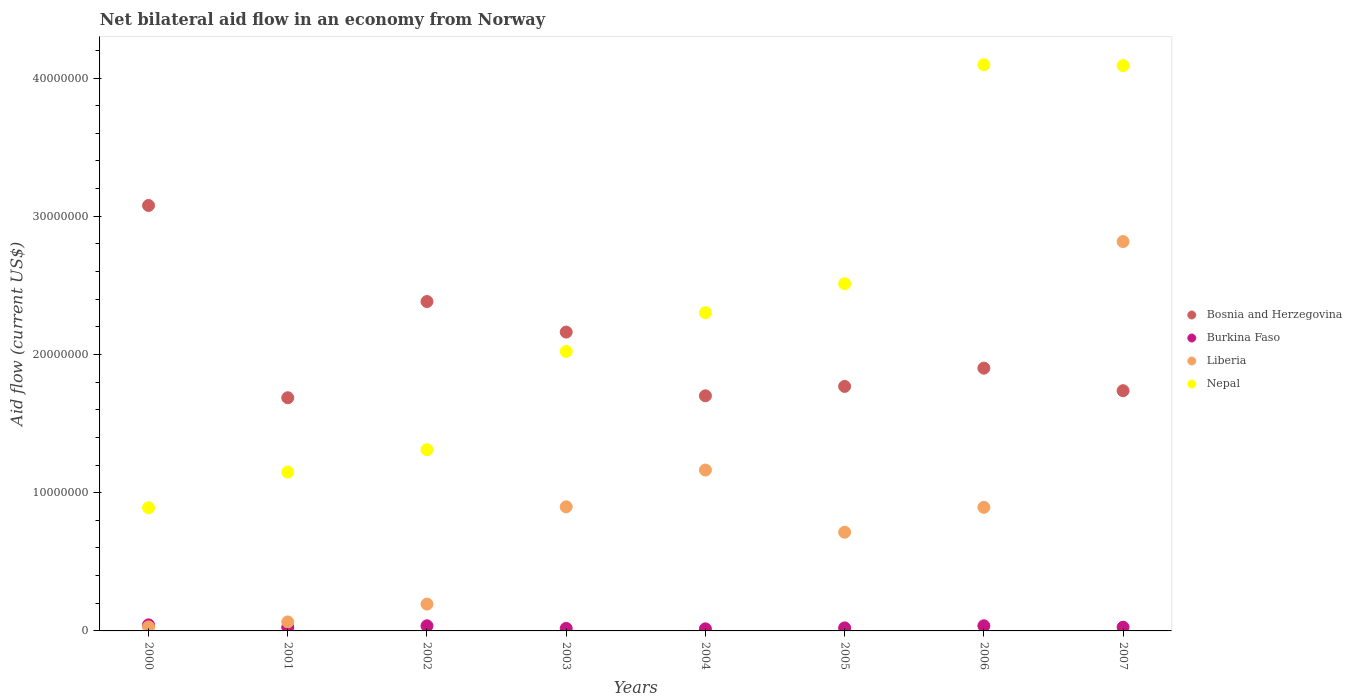How many different coloured dotlines are there?
Ensure brevity in your answer.  4. Is the number of dotlines equal to the number of legend labels?
Make the answer very short. Yes. What is the net bilateral aid flow in Burkina Faso in 2006?
Your response must be concise. 3.70e+05. Across all years, what is the maximum net bilateral aid flow in Liberia?
Give a very brief answer. 2.82e+07. Across all years, what is the minimum net bilateral aid flow in Liberia?
Provide a short and direct response. 2.90e+05. In which year was the net bilateral aid flow in Burkina Faso minimum?
Provide a short and direct response. 2004. What is the total net bilateral aid flow in Bosnia and Herzegovina in the graph?
Your answer should be very brief. 1.64e+08. What is the difference between the net bilateral aid flow in Nepal in 2000 and that in 2007?
Your answer should be compact. -3.20e+07. What is the difference between the net bilateral aid flow in Nepal in 2006 and the net bilateral aid flow in Liberia in 2002?
Provide a short and direct response. 3.90e+07. What is the average net bilateral aid flow in Liberia per year?
Your answer should be very brief. 8.47e+06. In the year 2006, what is the difference between the net bilateral aid flow in Burkina Faso and net bilateral aid flow in Bosnia and Herzegovina?
Provide a succinct answer. -1.86e+07. In how many years, is the net bilateral aid flow in Nepal greater than 16000000 US$?
Keep it short and to the point. 5. What is the ratio of the net bilateral aid flow in Bosnia and Herzegovina in 2001 to that in 2007?
Offer a very short reply. 0.97. Is the difference between the net bilateral aid flow in Burkina Faso in 2000 and 2002 greater than the difference between the net bilateral aid flow in Bosnia and Herzegovina in 2000 and 2002?
Ensure brevity in your answer.  No. What is the difference between the highest and the second highest net bilateral aid flow in Liberia?
Keep it short and to the point. 1.65e+07. What is the difference between the highest and the lowest net bilateral aid flow in Liberia?
Ensure brevity in your answer.  2.79e+07. In how many years, is the net bilateral aid flow in Bosnia and Herzegovina greater than the average net bilateral aid flow in Bosnia and Herzegovina taken over all years?
Make the answer very short. 3. Is the sum of the net bilateral aid flow in Liberia in 2001 and 2005 greater than the maximum net bilateral aid flow in Bosnia and Herzegovina across all years?
Keep it short and to the point. No. Is it the case that in every year, the sum of the net bilateral aid flow in Nepal and net bilateral aid flow in Liberia  is greater than the net bilateral aid flow in Bosnia and Herzegovina?
Your answer should be compact. No. Does the net bilateral aid flow in Bosnia and Herzegovina monotonically increase over the years?
Your answer should be very brief. No. Is the net bilateral aid flow in Liberia strictly greater than the net bilateral aid flow in Bosnia and Herzegovina over the years?
Keep it short and to the point. No. Is the net bilateral aid flow in Burkina Faso strictly less than the net bilateral aid flow in Bosnia and Herzegovina over the years?
Provide a short and direct response. Yes. Does the graph contain any zero values?
Give a very brief answer. No. How many legend labels are there?
Offer a terse response. 4. What is the title of the graph?
Make the answer very short. Net bilateral aid flow in an economy from Norway. Does "Kyrgyz Republic" appear as one of the legend labels in the graph?
Provide a succinct answer. No. What is the label or title of the Y-axis?
Your answer should be very brief. Aid flow (current US$). What is the Aid flow (current US$) in Bosnia and Herzegovina in 2000?
Make the answer very short. 3.08e+07. What is the Aid flow (current US$) in Burkina Faso in 2000?
Provide a succinct answer. 4.40e+05. What is the Aid flow (current US$) of Liberia in 2000?
Offer a very short reply. 2.90e+05. What is the Aid flow (current US$) in Nepal in 2000?
Keep it short and to the point. 8.91e+06. What is the Aid flow (current US$) in Bosnia and Herzegovina in 2001?
Give a very brief answer. 1.69e+07. What is the Aid flow (current US$) in Liberia in 2001?
Keep it short and to the point. 6.50e+05. What is the Aid flow (current US$) of Nepal in 2001?
Keep it short and to the point. 1.15e+07. What is the Aid flow (current US$) in Bosnia and Herzegovina in 2002?
Your answer should be very brief. 2.38e+07. What is the Aid flow (current US$) of Liberia in 2002?
Ensure brevity in your answer.  1.94e+06. What is the Aid flow (current US$) of Nepal in 2002?
Offer a terse response. 1.31e+07. What is the Aid flow (current US$) of Bosnia and Herzegovina in 2003?
Offer a terse response. 2.16e+07. What is the Aid flow (current US$) in Burkina Faso in 2003?
Ensure brevity in your answer.  1.80e+05. What is the Aid flow (current US$) of Liberia in 2003?
Provide a short and direct response. 8.98e+06. What is the Aid flow (current US$) of Nepal in 2003?
Keep it short and to the point. 2.02e+07. What is the Aid flow (current US$) of Bosnia and Herzegovina in 2004?
Keep it short and to the point. 1.70e+07. What is the Aid flow (current US$) of Liberia in 2004?
Your response must be concise. 1.16e+07. What is the Aid flow (current US$) of Nepal in 2004?
Offer a terse response. 2.30e+07. What is the Aid flow (current US$) in Bosnia and Herzegovina in 2005?
Ensure brevity in your answer.  1.77e+07. What is the Aid flow (current US$) of Burkina Faso in 2005?
Provide a succinct answer. 2.20e+05. What is the Aid flow (current US$) in Liberia in 2005?
Offer a very short reply. 7.14e+06. What is the Aid flow (current US$) in Nepal in 2005?
Offer a very short reply. 2.51e+07. What is the Aid flow (current US$) of Bosnia and Herzegovina in 2006?
Your response must be concise. 1.90e+07. What is the Aid flow (current US$) of Liberia in 2006?
Offer a terse response. 8.94e+06. What is the Aid flow (current US$) in Nepal in 2006?
Make the answer very short. 4.10e+07. What is the Aid flow (current US$) of Bosnia and Herzegovina in 2007?
Give a very brief answer. 1.74e+07. What is the Aid flow (current US$) in Liberia in 2007?
Offer a terse response. 2.82e+07. What is the Aid flow (current US$) in Nepal in 2007?
Your answer should be very brief. 4.09e+07. Across all years, what is the maximum Aid flow (current US$) of Bosnia and Herzegovina?
Give a very brief answer. 3.08e+07. Across all years, what is the maximum Aid flow (current US$) of Liberia?
Give a very brief answer. 2.82e+07. Across all years, what is the maximum Aid flow (current US$) in Nepal?
Give a very brief answer. 4.10e+07. Across all years, what is the minimum Aid flow (current US$) in Bosnia and Herzegovina?
Provide a succinct answer. 1.69e+07. Across all years, what is the minimum Aid flow (current US$) of Nepal?
Your answer should be compact. 8.91e+06. What is the total Aid flow (current US$) in Bosnia and Herzegovina in the graph?
Offer a very short reply. 1.64e+08. What is the total Aid flow (current US$) of Burkina Faso in the graph?
Your response must be concise. 2.27e+06. What is the total Aid flow (current US$) in Liberia in the graph?
Keep it short and to the point. 6.78e+07. What is the total Aid flow (current US$) in Nepal in the graph?
Your response must be concise. 1.84e+08. What is the difference between the Aid flow (current US$) of Bosnia and Herzegovina in 2000 and that in 2001?
Offer a terse response. 1.39e+07. What is the difference between the Aid flow (current US$) of Liberia in 2000 and that in 2001?
Make the answer very short. -3.60e+05. What is the difference between the Aid flow (current US$) of Nepal in 2000 and that in 2001?
Your response must be concise. -2.58e+06. What is the difference between the Aid flow (current US$) of Bosnia and Herzegovina in 2000 and that in 2002?
Ensure brevity in your answer.  6.95e+06. What is the difference between the Aid flow (current US$) of Burkina Faso in 2000 and that in 2002?
Your answer should be compact. 7.00e+04. What is the difference between the Aid flow (current US$) in Liberia in 2000 and that in 2002?
Provide a short and direct response. -1.65e+06. What is the difference between the Aid flow (current US$) in Nepal in 2000 and that in 2002?
Offer a terse response. -4.20e+06. What is the difference between the Aid flow (current US$) in Bosnia and Herzegovina in 2000 and that in 2003?
Your response must be concise. 9.16e+06. What is the difference between the Aid flow (current US$) in Liberia in 2000 and that in 2003?
Ensure brevity in your answer.  -8.69e+06. What is the difference between the Aid flow (current US$) in Nepal in 2000 and that in 2003?
Ensure brevity in your answer.  -1.13e+07. What is the difference between the Aid flow (current US$) in Bosnia and Herzegovina in 2000 and that in 2004?
Provide a short and direct response. 1.38e+07. What is the difference between the Aid flow (current US$) of Liberia in 2000 and that in 2004?
Keep it short and to the point. -1.14e+07. What is the difference between the Aid flow (current US$) of Nepal in 2000 and that in 2004?
Your response must be concise. -1.41e+07. What is the difference between the Aid flow (current US$) in Bosnia and Herzegovina in 2000 and that in 2005?
Provide a short and direct response. 1.31e+07. What is the difference between the Aid flow (current US$) of Burkina Faso in 2000 and that in 2005?
Ensure brevity in your answer.  2.20e+05. What is the difference between the Aid flow (current US$) of Liberia in 2000 and that in 2005?
Make the answer very short. -6.85e+06. What is the difference between the Aid flow (current US$) of Nepal in 2000 and that in 2005?
Ensure brevity in your answer.  -1.62e+07. What is the difference between the Aid flow (current US$) of Bosnia and Herzegovina in 2000 and that in 2006?
Offer a terse response. 1.18e+07. What is the difference between the Aid flow (current US$) in Liberia in 2000 and that in 2006?
Make the answer very short. -8.65e+06. What is the difference between the Aid flow (current US$) in Nepal in 2000 and that in 2006?
Keep it short and to the point. -3.20e+07. What is the difference between the Aid flow (current US$) in Bosnia and Herzegovina in 2000 and that in 2007?
Your answer should be very brief. 1.34e+07. What is the difference between the Aid flow (current US$) of Liberia in 2000 and that in 2007?
Give a very brief answer. -2.79e+07. What is the difference between the Aid flow (current US$) in Nepal in 2000 and that in 2007?
Provide a short and direct response. -3.20e+07. What is the difference between the Aid flow (current US$) of Bosnia and Herzegovina in 2001 and that in 2002?
Your answer should be compact. -6.96e+06. What is the difference between the Aid flow (current US$) of Liberia in 2001 and that in 2002?
Provide a short and direct response. -1.29e+06. What is the difference between the Aid flow (current US$) in Nepal in 2001 and that in 2002?
Ensure brevity in your answer.  -1.62e+06. What is the difference between the Aid flow (current US$) of Bosnia and Herzegovina in 2001 and that in 2003?
Offer a terse response. -4.75e+06. What is the difference between the Aid flow (current US$) of Liberia in 2001 and that in 2003?
Make the answer very short. -8.33e+06. What is the difference between the Aid flow (current US$) in Nepal in 2001 and that in 2003?
Give a very brief answer. -8.73e+06. What is the difference between the Aid flow (current US$) in Bosnia and Herzegovina in 2001 and that in 2004?
Ensure brevity in your answer.  -1.40e+05. What is the difference between the Aid flow (current US$) of Liberia in 2001 and that in 2004?
Your answer should be very brief. -1.10e+07. What is the difference between the Aid flow (current US$) in Nepal in 2001 and that in 2004?
Give a very brief answer. -1.15e+07. What is the difference between the Aid flow (current US$) of Bosnia and Herzegovina in 2001 and that in 2005?
Your answer should be very brief. -8.20e+05. What is the difference between the Aid flow (current US$) in Liberia in 2001 and that in 2005?
Offer a very short reply. -6.49e+06. What is the difference between the Aid flow (current US$) in Nepal in 2001 and that in 2005?
Keep it short and to the point. -1.36e+07. What is the difference between the Aid flow (current US$) of Bosnia and Herzegovina in 2001 and that in 2006?
Your answer should be very brief. -2.14e+06. What is the difference between the Aid flow (current US$) of Burkina Faso in 2001 and that in 2006?
Your response must be concise. -1.00e+05. What is the difference between the Aid flow (current US$) of Liberia in 2001 and that in 2006?
Provide a succinct answer. -8.29e+06. What is the difference between the Aid flow (current US$) of Nepal in 2001 and that in 2006?
Your response must be concise. -2.95e+07. What is the difference between the Aid flow (current US$) of Bosnia and Herzegovina in 2001 and that in 2007?
Offer a terse response. -5.10e+05. What is the difference between the Aid flow (current US$) of Burkina Faso in 2001 and that in 2007?
Your answer should be very brief. 0. What is the difference between the Aid flow (current US$) of Liberia in 2001 and that in 2007?
Offer a terse response. -2.75e+07. What is the difference between the Aid flow (current US$) of Nepal in 2001 and that in 2007?
Provide a succinct answer. -2.94e+07. What is the difference between the Aid flow (current US$) of Bosnia and Herzegovina in 2002 and that in 2003?
Your response must be concise. 2.21e+06. What is the difference between the Aid flow (current US$) in Burkina Faso in 2002 and that in 2003?
Make the answer very short. 1.90e+05. What is the difference between the Aid flow (current US$) of Liberia in 2002 and that in 2003?
Ensure brevity in your answer.  -7.04e+06. What is the difference between the Aid flow (current US$) of Nepal in 2002 and that in 2003?
Your response must be concise. -7.11e+06. What is the difference between the Aid flow (current US$) of Bosnia and Herzegovina in 2002 and that in 2004?
Offer a very short reply. 6.82e+06. What is the difference between the Aid flow (current US$) in Burkina Faso in 2002 and that in 2004?
Provide a short and direct response. 2.20e+05. What is the difference between the Aid flow (current US$) in Liberia in 2002 and that in 2004?
Make the answer very short. -9.70e+06. What is the difference between the Aid flow (current US$) in Nepal in 2002 and that in 2004?
Provide a short and direct response. -9.91e+06. What is the difference between the Aid flow (current US$) of Bosnia and Herzegovina in 2002 and that in 2005?
Provide a succinct answer. 6.14e+06. What is the difference between the Aid flow (current US$) in Liberia in 2002 and that in 2005?
Your answer should be very brief. -5.20e+06. What is the difference between the Aid flow (current US$) of Nepal in 2002 and that in 2005?
Provide a short and direct response. -1.20e+07. What is the difference between the Aid flow (current US$) in Bosnia and Herzegovina in 2002 and that in 2006?
Give a very brief answer. 4.82e+06. What is the difference between the Aid flow (current US$) in Liberia in 2002 and that in 2006?
Offer a very short reply. -7.00e+06. What is the difference between the Aid flow (current US$) in Nepal in 2002 and that in 2006?
Make the answer very short. -2.78e+07. What is the difference between the Aid flow (current US$) of Bosnia and Herzegovina in 2002 and that in 2007?
Keep it short and to the point. 6.45e+06. What is the difference between the Aid flow (current US$) of Burkina Faso in 2002 and that in 2007?
Make the answer very short. 1.00e+05. What is the difference between the Aid flow (current US$) of Liberia in 2002 and that in 2007?
Ensure brevity in your answer.  -2.62e+07. What is the difference between the Aid flow (current US$) of Nepal in 2002 and that in 2007?
Provide a succinct answer. -2.78e+07. What is the difference between the Aid flow (current US$) in Bosnia and Herzegovina in 2003 and that in 2004?
Make the answer very short. 4.61e+06. What is the difference between the Aid flow (current US$) in Liberia in 2003 and that in 2004?
Provide a succinct answer. -2.66e+06. What is the difference between the Aid flow (current US$) of Nepal in 2003 and that in 2004?
Offer a very short reply. -2.80e+06. What is the difference between the Aid flow (current US$) of Bosnia and Herzegovina in 2003 and that in 2005?
Your answer should be very brief. 3.93e+06. What is the difference between the Aid flow (current US$) in Liberia in 2003 and that in 2005?
Your response must be concise. 1.84e+06. What is the difference between the Aid flow (current US$) in Nepal in 2003 and that in 2005?
Offer a very short reply. -4.90e+06. What is the difference between the Aid flow (current US$) in Bosnia and Herzegovina in 2003 and that in 2006?
Ensure brevity in your answer.  2.61e+06. What is the difference between the Aid flow (current US$) of Burkina Faso in 2003 and that in 2006?
Give a very brief answer. -1.90e+05. What is the difference between the Aid flow (current US$) in Liberia in 2003 and that in 2006?
Provide a short and direct response. 4.00e+04. What is the difference between the Aid flow (current US$) in Nepal in 2003 and that in 2006?
Make the answer very short. -2.07e+07. What is the difference between the Aid flow (current US$) in Bosnia and Herzegovina in 2003 and that in 2007?
Offer a terse response. 4.24e+06. What is the difference between the Aid flow (current US$) in Burkina Faso in 2003 and that in 2007?
Make the answer very short. -9.00e+04. What is the difference between the Aid flow (current US$) in Liberia in 2003 and that in 2007?
Your answer should be very brief. -1.92e+07. What is the difference between the Aid flow (current US$) of Nepal in 2003 and that in 2007?
Offer a terse response. -2.07e+07. What is the difference between the Aid flow (current US$) in Bosnia and Herzegovina in 2004 and that in 2005?
Your answer should be very brief. -6.80e+05. What is the difference between the Aid flow (current US$) of Liberia in 2004 and that in 2005?
Provide a succinct answer. 4.50e+06. What is the difference between the Aid flow (current US$) of Nepal in 2004 and that in 2005?
Your response must be concise. -2.10e+06. What is the difference between the Aid flow (current US$) in Bosnia and Herzegovina in 2004 and that in 2006?
Your answer should be compact. -2.00e+06. What is the difference between the Aid flow (current US$) in Burkina Faso in 2004 and that in 2006?
Give a very brief answer. -2.20e+05. What is the difference between the Aid flow (current US$) of Liberia in 2004 and that in 2006?
Your answer should be very brief. 2.70e+06. What is the difference between the Aid flow (current US$) in Nepal in 2004 and that in 2006?
Give a very brief answer. -1.79e+07. What is the difference between the Aid flow (current US$) of Bosnia and Herzegovina in 2004 and that in 2007?
Make the answer very short. -3.70e+05. What is the difference between the Aid flow (current US$) in Burkina Faso in 2004 and that in 2007?
Give a very brief answer. -1.20e+05. What is the difference between the Aid flow (current US$) of Liberia in 2004 and that in 2007?
Provide a succinct answer. -1.65e+07. What is the difference between the Aid flow (current US$) of Nepal in 2004 and that in 2007?
Keep it short and to the point. -1.79e+07. What is the difference between the Aid flow (current US$) in Bosnia and Herzegovina in 2005 and that in 2006?
Make the answer very short. -1.32e+06. What is the difference between the Aid flow (current US$) in Burkina Faso in 2005 and that in 2006?
Make the answer very short. -1.50e+05. What is the difference between the Aid flow (current US$) of Liberia in 2005 and that in 2006?
Your answer should be very brief. -1.80e+06. What is the difference between the Aid flow (current US$) of Nepal in 2005 and that in 2006?
Offer a very short reply. -1.58e+07. What is the difference between the Aid flow (current US$) in Bosnia and Herzegovina in 2005 and that in 2007?
Your answer should be very brief. 3.10e+05. What is the difference between the Aid flow (current US$) of Liberia in 2005 and that in 2007?
Provide a succinct answer. -2.10e+07. What is the difference between the Aid flow (current US$) in Nepal in 2005 and that in 2007?
Provide a short and direct response. -1.58e+07. What is the difference between the Aid flow (current US$) in Bosnia and Herzegovina in 2006 and that in 2007?
Give a very brief answer. 1.63e+06. What is the difference between the Aid flow (current US$) of Liberia in 2006 and that in 2007?
Give a very brief answer. -1.92e+07. What is the difference between the Aid flow (current US$) of Bosnia and Herzegovina in 2000 and the Aid flow (current US$) of Burkina Faso in 2001?
Your answer should be compact. 3.05e+07. What is the difference between the Aid flow (current US$) in Bosnia and Herzegovina in 2000 and the Aid flow (current US$) in Liberia in 2001?
Provide a succinct answer. 3.01e+07. What is the difference between the Aid flow (current US$) of Bosnia and Herzegovina in 2000 and the Aid flow (current US$) of Nepal in 2001?
Give a very brief answer. 1.93e+07. What is the difference between the Aid flow (current US$) in Burkina Faso in 2000 and the Aid flow (current US$) in Liberia in 2001?
Make the answer very short. -2.10e+05. What is the difference between the Aid flow (current US$) in Burkina Faso in 2000 and the Aid flow (current US$) in Nepal in 2001?
Your answer should be very brief. -1.10e+07. What is the difference between the Aid flow (current US$) of Liberia in 2000 and the Aid flow (current US$) of Nepal in 2001?
Provide a succinct answer. -1.12e+07. What is the difference between the Aid flow (current US$) in Bosnia and Herzegovina in 2000 and the Aid flow (current US$) in Burkina Faso in 2002?
Offer a very short reply. 3.04e+07. What is the difference between the Aid flow (current US$) in Bosnia and Herzegovina in 2000 and the Aid flow (current US$) in Liberia in 2002?
Make the answer very short. 2.88e+07. What is the difference between the Aid flow (current US$) in Bosnia and Herzegovina in 2000 and the Aid flow (current US$) in Nepal in 2002?
Provide a succinct answer. 1.77e+07. What is the difference between the Aid flow (current US$) in Burkina Faso in 2000 and the Aid flow (current US$) in Liberia in 2002?
Provide a short and direct response. -1.50e+06. What is the difference between the Aid flow (current US$) of Burkina Faso in 2000 and the Aid flow (current US$) of Nepal in 2002?
Your answer should be compact. -1.27e+07. What is the difference between the Aid flow (current US$) of Liberia in 2000 and the Aid flow (current US$) of Nepal in 2002?
Give a very brief answer. -1.28e+07. What is the difference between the Aid flow (current US$) in Bosnia and Herzegovina in 2000 and the Aid flow (current US$) in Burkina Faso in 2003?
Ensure brevity in your answer.  3.06e+07. What is the difference between the Aid flow (current US$) in Bosnia and Herzegovina in 2000 and the Aid flow (current US$) in Liberia in 2003?
Ensure brevity in your answer.  2.18e+07. What is the difference between the Aid flow (current US$) in Bosnia and Herzegovina in 2000 and the Aid flow (current US$) in Nepal in 2003?
Make the answer very short. 1.06e+07. What is the difference between the Aid flow (current US$) of Burkina Faso in 2000 and the Aid flow (current US$) of Liberia in 2003?
Offer a terse response. -8.54e+06. What is the difference between the Aid flow (current US$) of Burkina Faso in 2000 and the Aid flow (current US$) of Nepal in 2003?
Your answer should be very brief. -1.98e+07. What is the difference between the Aid flow (current US$) of Liberia in 2000 and the Aid flow (current US$) of Nepal in 2003?
Offer a terse response. -1.99e+07. What is the difference between the Aid flow (current US$) in Bosnia and Herzegovina in 2000 and the Aid flow (current US$) in Burkina Faso in 2004?
Offer a very short reply. 3.06e+07. What is the difference between the Aid flow (current US$) in Bosnia and Herzegovina in 2000 and the Aid flow (current US$) in Liberia in 2004?
Provide a short and direct response. 1.91e+07. What is the difference between the Aid flow (current US$) in Bosnia and Herzegovina in 2000 and the Aid flow (current US$) in Nepal in 2004?
Offer a very short reply. 7.76e+06. What is the difference between the Aid flow (current US$) of Burkina Faso in 2000 and the Aid flow (current US$) of Liberia in 2004?
Your answer should be compact. -1.12e+07. What is the difference between the Aid flow (current US$) of Burkina Faso in 2000 and the Aid flow (current US$) of Nepal in 2004?
Ensure brevity in your answer.  -2.26e+07. What is the difference between the Aid flow (current US$) of Liberia in 2000 and the Aid flow (current US$) of Nepal in 2004?
Your response must be concise. -2.27e+07. What is the difference between the Aid flow (current US$) of Bosnia and Herzegovina in 2000 and the Aid flow (current US$) of Burkina Faso in 2005?
Ensure brevity in your answer.  3.06e+07. What is the difference between the Aid flow (current US$) of Bosnia and Herzegovina in 2000 and the Aid flow (current US$) of Liberia in 2005?
Provide a short and direct response. 2.36e+07. What is the difference between the Aid flow (current US$) of Bosnia and Herzegovina in 2000 and the Aid flow (current US$) of Nepal in 2005?
Give a very brief answer. 5.66e+06. What is the difference between the Aid flow (current US$) in Burkina Faso in 2000 and the Aid flow (current US$) in Liberia in 2005?
Keep it short and to the point. -6.70e+06. What is the difference between the Aid flow (current US$) of Burkina Faso in 2000 and the Aid flow (current US$) of Nepal in 2005?
Keep it short and to the point. -2.47e+07. What is the difference between the Aid flow (current US$) in Liberia in 2000 and the Aid flow (current US$) in Nepal in 2005?
Offer a terse response. -2.48e+07. What is the difference between the Aid flow (current US$) in Bosnia and Herzegovina in 2000 and the Aid flow (current US$) in Burkina Faso in 2006?
Your response must be concise. 3.04e+07. What is the difference between the Aid flow (current US$) in Bosnia and Herzegovina in 2000 and the Aid flow (current US$) in Liberia in 2006?
Your response must be concise. 2.18e+07. What is the difference between the Aid flow (current US$) in Bosnia and Herzegovina in 2000 and the Aid flow (current US$) in Nepal in 2006?
Provide a short and direct response. -1.02e+07. What is the difference between the Aid flow (current US$) in Burkina Faso in 2000 and the Aid flow (current US$) in Liberia in 2006?
Offer a terse response. -8.50e+06. What is the difference between the Aid flow (current US$) in Burkina Faso in 2000 and the Aid flow (current US$) in Nepal in 2006?
Provide a succinct answer. -4.05e+07. What is the difference between the Aid flow (current US$) of Liberia in 2000 and the Aid flow (current US$) of Nepal in 2006?
Your response must be concise. -4.07e+07. What is the difference between the Aid flow (current US$) in Bosnia and Herzegovina in 2000 and the Aid flow (current US$) in Burkina Faso in 2007?
Your answer should be compact. 3.05e+07. What is the difference between the Aid flow (current US$) of Bosnia and Herzegovina in 2000 and the Aid flow (current US$) of Liberia in 2007?
Keep it short and to the point. 2.61e+06. What is the difference between the Aid flow (current US$) of Bosnia and Herzegovina in 2000 and the Aid flow (current US$) of Nepal in 2007?
Offer a very short reply. -1.01e+07. What is the difference between the Aid flow (current US$) in Burkina Faso in 2000 and the Aid flow (current US$) in Liberia in 2007?
Your answer should be compact. -2.77e+07. What is the difference between the Aid flow (current US$) of Burkina Faso in 2000 and the Aid flow (current US$) of Nepal in 2007?
Give a very brief answer. -4.05e+07. What is the difference between the Aid flow (current US$) in Liberia in 2000 and the Aid flow (current US$) in Nepal in 2007?
Your response must be concise. -4.06e+07. What is the difference between the Aid flow (current US$) of Bosnia and Herzegovina in 2001 and the Aid flow (current US$) of Burkina Faso in 2002?
Ensure brevity in your answer.  1.65e+07. What is the difference between the Aid flow (current US$) of Bosnia and Herzegovina in 2001 and the Aid flow (current US$) of Liberia in 2002?
Keep it short and to the point. 1.49e+07. What is the difference between the Aid flow (current US$) of Bosnia and Herzegovina in 2001 and the Aid flow (current US$) of Nepal in 2002?
Offer a very short reply. 3.76e+06. What is the difference between the Aid flow (current US$) of Burkina Faso in 2001 and the Aid flow (current US$) of Liberia in 2002?
Provide a succinct answer. -1.67e+06. What is the difference between the Aid flow (current US$) in Burkina Faso in 2001 and the Aid flow (current US$) in Nepal in 2002?
Provide a succinct answer. -1.28e+07. What is the difference between the Aid flow (current US$) of Liberia in 2001 and the Aid flow (current US$) of Nepal in 2002?
Provide a short and direct response. -1.25e+07. What is the difference between the Aid flow (current US$) of Bosnia and Herzegovina in 2001 and the Aid flow (current US$) of Burkina Faso in 2003?
Offer a very short reply. 1.67e+07. What is the difference between the Aid flow (current US$) in Bosnia and Herzegovina in 2001 and the Aid flow (current US$) in Liberia in 2003?
Provide a short and direct response. 7.89e+06. What is the difference between the Aid flow (current US$) of Bosnia and Herzegovina in 2001 and the Aid flow (current US$) of Nepal in 2003?
Your response must be concise. -3.35e+06. What is the difference between the Aid flow (current US$) in Burkina Faso in 2001 and the Aid flow (current US$) in Liberia in 2003?
Make the answer very short. -8.71e+06. What is the difference between the Aid flow (current US$) in Burkina Faso in 2001 and the Aid flow (current US$) in Nepal in 2003?
Provide a succinct answer. -2.00e+07. What is the difference between the Aid flow (current US$) in Liberia in 2001 and the Aid flow (current US$) in Nepal in 2003?
Your answer should be very brief. -1.96e+07. What is the difference between the Aid flow (current US$) of Bosnia and Herzegovina in 2001 and the Aid flow (current US$) of Burkina Faso in 2004?
Make the answer very short. 1.67e+07. What is the difference between the Aid flow (current US$) in Bosnia and Herzegovina in 2001 and the Aid flow (current US$) in Liberia in 2004?
Keep it short and to the point. 5.23e+06. What is the difference between the Aid flow (current US$) in Bosnia and Herzegovina in 2001 and the Aid flow (current US$) in Nepal in 2004?
Your answer should be very brief. -6.15e+06. What is the difference between the Aid flow (current US$) of Burkina Faso in 2001 and the Aid flow (current US$) of Liberia in 2004?
Your answer should be very brief. -1.14e+07. What is the difference between the Aid flow (current US$) of Burkina Faso in 2001 and the Aid flow (current US$) of Nepal in 2004?
Ensure brevity in your answer.  -2.28e+07. What is the difference between the Aid flow (current US$) in Liberia in 2001 and the Aid flow (current US$) in Nepal in 2004?
Your answer should be compact. -2.24e+07. What is the difference between the Aid flow (current US$) of Bosnia and Herzegovina in 2001 and the Aid flow (current US$) of Burkina Faso in 2005?
Your answer should be compact. 1.66e+07. What is the difference between the Aid flow (current US$) of Bosnia and Herzegovina in 2001 and the Aid flow (current US$) of Liberia in 2005?
Provide a short and direct response. 9.73e+06. What is the difference between the Aid flow (current US$) of Bosnia and Herzegovina in 2001 and the Aid flow (current US$) of Nepal in 2005?
Your answer should be compact. -8.25e+06. What is the difference between the Aid flow (current US$) in Burkina Faso in 2001 and the Aid flow (current US$) in Liberia in 2005?
Ensure brevity in your answer.  -6.87e+06. What is the difference between the Aid flow (current US$) in Burkina Faso in 2001 and the Aid flow (current US$) in Nepal in 2005?
Provide a short and direct response. -2.48e+07. What is the difference between the Aid flow (current US$) in Liberia in 2001 and the Aid flow (current US$) in Nepal in 2005?
Your answer should be compact. -2.45e+07. What is the difference between the Aid flow (current US$) in Bosnia and Herzegovina in 2001 and the Aid flow (current US$) in Burkina Faso in 2006?
Make the answer very short. 1.65e+07. What is the difference between the Aid flow (current US$) of Bosnia and Herzegovina in 2001 and the Aid flow (current US$) of Liberia in 2006?
Offer a terse response. 7.93e+06. What is the difference between the Aid flow (current US$) of Bosnia and Herzegovina in 2001 and the Aid flow (current US$) of Nepal in 2006?
Ensure brevity in your answer.  -2.41e+07. What is the difference between the Aid flow (current US$) in Burkina Faso in 2001 and the Aid flow (current US$) in Liberia in 2006?
Provide a succinct answer. -8.67e+06. What is the difference between the Aid flow (current US$) of Burkina Faso in 2001 and the Aid flow (current US$) of Nepal in 2006?
Offer a terse response. -4.07e+07. What is the difference between the Aid flow (current US$) of Liberia in 2001 and the Aid flow (current US$) of Nepal in 2006?
Your response must be concise. -4.03e+07. What is the difference between the Aid flow (current US$) of Bosnia and Herzegovina in 2001 and the Aid flow (current US$) of Burkina Faso in 2007?
Offer a terse response. 1.66e+07. What is the difference between the Aid flow (current US$) in Bosnia and Herzegovina in 2001 and the Aid flow (current US$) in Liberia in 2007?
Offer a terse response. -1.13e+07. What is the difference between the Aid flow (current US$) in Bosnia and Herzegovina in 2001 and the Aid flow (current US$) in Nepal in 2007?
Ensure brevity in your answer.  -2.40e+07. What is the difference between the Aid flow (current US$) of Burkina Faso in 2001 and the Aid flow (current US$) of Liberia in 2007?
Your answer should be compact. -2.79e+07. What is the difference between the Aid flow (current US$) in Burkina Faso in 2001 and the Aid flow (current US$) in Nepal in 2007?
Keep it short and to the point. -4.06e+07. What is the difference between the Aid flow (current US$) of Liberia in 2001 and the Aid flow (current US$) of Nepal in 2007?
Make the answer very short. -4.02e+07. What is the difference between the Aid flow (current US$) of Bosnia and Herzegovina in 2002 and the Aid flow (current US$) of Burkina Faso in 2003?
Make the answer very short. 2.36e+07. What is the difference between the Aid flow (current US$) in Bosnia and Herzegovina in 2002 and the Aid flow (current US$) in Liberia in 2003?
Give a very brief answer. 1.48e+07. What is the difference between the Aid flow (current US$) of Bosnia and Herzegovina in 2002 and the Aid flow (current US$) of Nepal in 2003?
Keep it short and to the point. 3.61e+06. What is the difference between the Aid flow (current US$) in Burkina Faso in 2002 and the Aid flow (current US$) in Liberia in 2003?
Offer a very short reply. -8.61e+06. What is the difference between the Aid flow (current US$) of Burkina Faso in 2002 and the Aid flow (current US$) of Nepal in 2003?
Your response must be concise. -1.98e+07. What is the difference between the Aid flow (current US$) in Liberia in 2002 and the Aid flow (current US$) in Nepal in 2003?
Give a very brief answer. -1.83e+07. What is the difference between the Aid flow (current US$) in Bosnia and Herzegovina in 2002 and the Aid flow (current US$) in Burkina Faso in 2004?
Offer a very short reply. 2.37e+07. What is the difference between the Aid flow (current US$) of Bosnia and Herzegovina in 2002 and the Aid flow (current US$) of Liberia in 2004?
Offer a very short reply. 1.22e+07. What is the difference between the Aid flow (current US$) in Bosnia and Herzegovina in 2002 and the Aid flow (current US$) in Nepal in 2004?
Make the answer very short. 8.10e+05. What is the difference between the Aid flow (current US$) of Burkina Faso in 2002 and the Aid flow (current US$) of Liberia in 2004?
Your answer should be very brief. -1.13e+07. What is the difference between the Aid flow (current US$) of Burkina Faso in 2002 and the Aid flow (current US$) of Nepal in 2004?
Provide a short and direct response. -2.26e+07. What is the difference between the Aid flow (current US$) in Liberia in 2002 and the Aid flow (current US$) in Nepal in 2004?
Offer a terse response. -2.11e+07. What is the difference between the Aid flow (current US$) in Bosnia and Herzegovina in 2002 and the Aid flow (current US$) in Burkina Faso in 2005?
Make the answer very short. 2.36e+07. What is the difference between the Aid flow (current US$) of Bosnia and Herzegovina in 2002 and the Aid flow (current US$) of Liberia in 2005?
Your answer should be compact. 1.67e+07. What is the difference between the Aid flow (current US$) in Bosnia and Herzegovina in 2002 and the Aid flow (current US$) in Nepal in 2005?
Your answer should be very brief. -1.29e+06. What is the difference between the Aid flow (current US$) of Burkina Faso in 2002 and the Aid flow (current US$) of Liberia in 2005?
Offer a terse response. -6.77e+06. What is the difference between the Aid flow (current US$) of Burkina Faso in 2002 and the Aid flow (current US$) of Nepal in 2005?
Your answer should be very brief. -2.48e+07. What is the difference between the Aid flow (current US$) in Liberia in 2002 and the Aid flow (current US$) in Nepal in 2005?
Your response must be concise. -2.32e+07. What is the difference between the Aid flow (current US$) in Bosnia and Herzegovina in 2002 and the Aid flow (current US$) in Burkina Faso in 2006?
Keep it short and to the point. 2.35e+07. What is the difference between the Aid flow (current US$) in Bosnia and Herzegovina in 2002 and the Aid flow (current US$) in Liberia in 2006?
Offer a terse response. 1.49e+07. What is the difference between the Aid flow (current US$) in Bosnia and Herzegovina in 2002 and the Aid flow (current US$) in Nepal in 2006?
Provide a short and direct response. -1.71e+07. What is the difference between the Aid flow (current US$) of Burkina Faso in 2002 and the Aid flow (current US$) of Liberia in 2006?
Offer a very short reply. -8.57e+06. What is the difference between the Aid flow (current US$) in Burkina Faso in 2002 and the Aid flow (current US$) in Nepal in 2006?
Provide a short and direct response. -4.06e+07. What is the difference between the Aid flow (current US$) in Liberia in 2002 and the Aid flow (current US$) in Nepal in 2006?
Give a very brief answer. -3.90e+07. What is the difference between the Aid flow (current US$) of Bosnia and Herzegovina in 2002 and the Aid flow (current US$) of Burkina Faso in 2007?
Keep it short and to the point. 2.36e+07. What is the difference between the Aid flow (current US$) in Bosnia and Herzegovina in 2002 and the Aid flow (current US$) in Liberia in 2007?
Provide a succinct answer. -4.34e+06. What is the difference between the Aid flow (current US$) in Bosnia and Herzegovina in 2002 and the Aid flow (current US$) in Nepal in 2007?
Give a very brief answer. -1.71e+07. What is the difference between the Aid flow (current US$) of Burkina Faso in 2002 and the Aid flow (current US$) of Liberia in 2007?
Your answer should be very brief. -2.78e+07. What is the difference between the Aid flow (current US$) of Burkina Faso in 2002 and the Aid flow (current US$) of Nepal in 2007?
Offer a very short reply. -4.05e+07. What is the difference between the Aid flow (current US$) in Liberia in 2002 and the Aid flow (current US$) in Nepal in 2007?
Keep it short and to the point. -3.90e+07. What is the difference between the Aid flow (current US$) of Bosnia and Herzegovina in 2003 and the Aid flow (current US$) of Burkina Faso in 2004?
Your answer should be very brief. 2.15e+07. What is the difference between the Aid flow (current US$) of Bosnia and Herzegovina in 2003 and the Aid flow (current US$) of Liberia in 2004?
Give a very brief answer. 9.98e+06. What is the difference between the Aid flow (current US$) in Bosnia and Herzegovina in 2003 and the Aid flow (current US$) in Nepal in 2004?
Provide a succinct answer. -1.40e+06. What is the difference between the Aid flow (current US$) in Burkina Faso in 2003 and the Aid flow (current US$) in Liberia in 2004?
Your answer should be very brief. -1.15e+07. What is the difference between the Aid flow (current US$) in Burkina Faso in 2003 and the Aid flow (current US$) in Nepal in 2004?
Your answer should be very brief. -2.28e+07. What is the difference between the Aid flow (current US$) in Liberia in 2003 and the Aid flow (current US$) in Nepal in 2004?
Your answer should be very brief. -1.40e+07. What is the difference between the Aid flow (current US$) in Bosnia and Herzegovina in 2003 and the Aid flow (current US$) in Burkina Faso in 2005?
Ensure brevity in your answer.  2.14e+07. What is the difference between the Aid flow (current US$) of Bosnia and Herzegovina in 2003 and the Aid flow (current US$) of Liberia in 2005?
Provide a succinct answer. 1.45e+07. What is the difference between the Aid flow (current US$) of Bosnia and Herzegovina in 2003 and the Aid flow (current US$) of Nepal in 2005?
Ensure brevity in your answer.  -3.50e+06. What is the difference between the Aid flow (current US$) of Burkina Faso in 2003 and the Aid flow (current US$) of Liberia in 2005?
Provide a succinct answer. -6.96e+06. What is the difference between the Aid flow (current US$) of Burkina Faso in 2003 and the Aid flow (current US$) of Nepal in 2005?
Your answer should be compact. -2.49e+07. What is the difference between the Aid flow (current US$) in Liberia in 2003 and the Aid flow (current US$) in Nepal in 2005?
Your answer should be compact. -1.61e+07. What is the difference between the Aid flow (current US$) in Bosnia and Herzegovina in 2003 and the Aid flow (current US$) in Burkina Faso in 2006?
Your response must be concise. 2.12e+07. What is the difference between the Aid flow (current US$) in Bosnia and Herzegovina in 2003 and the Aid flow (current US$) in Liberia in 2006?
Provide a short and direct response. 1.27e+07. What is the difference between the Aid flow (current US$) in Bosnia and Herzegovina in 2003 and the Aid flow (current US$) in Nepal in 2006?
Make the answer very short. -1.93e+07. What is the difference between the Aid flow (current US$) in Burkina Faso in 2003 and the Aid flow (current US$) in Liberia in 2006?
Your answer should be very brief. -8.76e+06. What is the difference between the Aid flow (current US$) of Burkina Faso in 2003 and the Aid flow (current US$) of Nepal in 2006?
Give a very brief answer. -4.08e+07. What is the difference between the Aid flow (current US$) of Liberia in 2003 and the Aid flow (current US$) of Nepal in 2006?
Offer a very short reply. -3.20e+07. What is the difference between the Aid flow (current US$) of Bosnia and Herzegovina in 2003 and the Aid flow (current US$) of Burkina Faso in 2007?
Your answer should be very brief. 2.14e+07. What is the difference between the Aid flow (current US$) in Bosnia and Herzegovina in 2003 and the Aid flow (current US$) in Liberia in 2007?
Offer a very short reply. -6.55e+06. What is the difference between the Aid flow (current US$) of Bosnia and Herzegovina in 2003 and the Aid flow (current US$) of Nepal in 2007?
Your answer should be compact. -1.93e+07. What is the difference between the Aid flow (current US$) in Burkina Faso in 2003 and the Aid flow (current US$) in Liberia in 2007?
Your answer should be very brief. -2.80e+07. What is the difference between the Aid flow (current US$) in Burkina Faso in 2003 and the Aid flow (current US$) in Nepal in 2007?
Provide a short and direct response. -4.07e+07. What is the difference between the Aid flow (current US$) of Liberia in 2003 and the Aid flow (current US$) of Nepal in 2007?
Offer a very short reply. -3.19e+07. What is the difference between the Aid flow (current US$) in Bosnia and Herzegovina in 2004 and the Aid flow (current US$) in Burkina Faso in 2005?
Provide a succinct answer. 1.68e+07. What is the difference between the Aid flow (current US$) in Bosnia and Herzegovina in 2004 and the Aid flow (current US$) in Liberia in 2005?
Make the answer very short. 9.87e+06. What is the difference between the Aid flow (current US$) of Bosnia and Herzegovina in 2004 and the Aid flow (current US$) of Nepal in 2005?
Offer a terse response. -8.11e+06. What is the difference between the Aid flow (current US$) in Burkina Faso in 2004 and the Aid flow (current US$) in Liberia in 2005?
Your answer should be compact. -6.99e+06. What is the difference between the Aid flow (current US$) of Burkina Faso in 2004 and the Aid flow (current US$) of Nepal in 2005?
Your answer should be compact. -2.50e+07. What is the difference between the Aid flow (current US$) in Liberia in 2004 and the Aid flow (current US$) in Nepal in 2005?
Make the answer very short. -1.35e+07. What is the difference between the Aid flow (current US$) of Bosnia and Herzegovina in 2004 and the Aid flow (current US$) of Burkina Faso in 2006?
Give a very brief answer. 1.66e+07. What is the difference between the Aid flow (current US$) of Bosnia and Herzegovina in 2004 and the Aid flow (current US$) of Liberia in 2006?
Keep it short and to the point. 8.07e+06. What is the difference between the Aid flow (current US$) of Bosnia and Herzegovina in 2004 and the Aid flow (current US$) of Nepal in 2006?
Provide a short and direct response. -2.40e+07. What is the difference between the Aid flow (current US$) of Burkina Faso in 2004 and the Aid flow (current US$) of Liberia in 2006?
Your answer should be very brief. -8.79e+06. What is the difference between the Aid flow (current US$) in Burkina Faso in 2004 and the Aid flow (current US$) in Nepal in 2006?
Give a very brief answer. -4.08e+07. What is the difference between the Aid flow (current US$) of Liberia in 2004 and the Aid flow (current US$) of Nepal in 2006?
Your response must be concise. -2.93e+07. What is the difference between the Aid flow (current US$) in Bosnia and Herzegovina in 2004 and the Aid flow (current US$) in Burkina Faso in 2007?
Make the answer very short. 1.67e+07. What is the difference between the Aid flow (current US$) in Bosnia and Herzegovina in 2004 and the Aid flow (current US$) in Liberia in 2007?
Ensure brevity in your answer.  -1.12e+07. What is the difference between the Aid flow (current US$) in Bosnia and Herzegovina in 2004 and the Aid flow (current US$) in Nepal in 2007?
Give a very brief answer. -2.39e+07. What is the difference between the Aid flow (current US$) in Burkina Faso in 2004 and the Aid flow (current US$) in Liberia in 2007?
Keep it short and to the point. -2.80e+07. What is the difference between the Aid flow (current US$) of Burkina Faso in 2004 and the Aid flow (current US$) of Nepal in 2007?
Provide a succinct answer. -4.08e+07. What is the difference between the Aid flow (current US$) of Liberia in 2004 and the Aid flow (current US$) of Nepal in 2007?
Ensure brevity in your answer.  -2.93e+07. What is the difference between the Aid flow (current US$) of Bosnia and Herzegovina in 2005 and the Aid flow (current US$) of Burkina Faso in 2006?
Your answer should be compact. 1.73e+07. What is the difference between the Aid flow (current US$) in Bosnia and Herzegovina in 2005 and the Aid flow (current US$) in Liberia in 2006?
Your response must be concise. 8.75e+06. What is the difference between the Aid flow (current US$) in Bosnia and Herzegovina in 2005 and the Aid flow (current US$) in Nepal in 2006?
Give a very brief answer. -2.33e+07. What is the difference between the Aid flow (current US$) of Burkina Faso in 2005 and the Aid flow (current US$) of Liberia in 2006?
Provide a succinct answer. -8.72e+06. What is the difference between the Aid flow (current US$) in Burkina Faso in 2005 and the Aid flow (current US$) in Nepal in 2006?
Your answer should be very brief. -4.07e+07. What is the difference between the Aid flow (current US$) of Liberia in 2005 and the Aid flow (current US$) of Nepal in 2006?
Your answer should be very brief. -3.38e+07. What is the difference between the Aid flow (current US$) in Bosnia and Herzegovina in 2005 and the Aid flow (current US$) in Burkina Faso in 2007?
Provide a short and direct response. 1.74e+07. What is the difference between the Aid flow (current US$) of Bosnia and Herzegovina in 2005 and the Aid flow (current US$) of Liberia in 2007?
Offer a very short reply. -1.05e+07. What is the difference between the Aid flow (current US$) of Bosnia and Herzegovina in 2005 and the Aid flow (current US$) of Nepal in 2007?
Offer a terse response. -2.32e+07. What is the difference between the Aid flow (current US$) in Burkina Faso in 2005 and the Aid flow (current US$) in Liberia in 2007?
Provide a succinct answer. -2.80e+07. What is the difference between the Aid flow (current US$) of Burkina Faso in 2005 and the Aid flow (current US$) of Nepal in 2007?
Provide a succinct answer. -4.07e+07. What is the difference between the Aid flow (current US$) of Liberia in 2005 and the Aid flow (current US$) of Nepal in 2007?
Your answer should be very brief. -3.38e+07. What is the difference between the Aid flow (current US$) of Bosnia and Herzegovina in 2006 and the Aid flow (current US$) of Burkina Faso in 2007?
Your answer should be very brief. 1.87e+07. What is the difference between the Aid flow (current US$) in Bosnia and Herzegovina in 2006 and the Aid flow (current US$) in Liberia in 2007?
Offer a terse response. -9.16e+06. What is the difference between the Aid flow (current US$) in Bosnia and Herzegovina in 2006 and the Aid flow (current US$) in Nepal in 2007?
Your answer should be compact. -2.19e+07. What is the difference between the Aid flow (current US$) of Burkina Faso in 2006 and the Aid flow (current US$) of Liberia in 2007?
Offer a very short reply. -2.78e+07. What is the difference between the Aid flow (current US$) of Burkina Faso in 2006 and the Aid flow (current US$) of Nepal in 2007?
Keep it short and to the point. -4.05e+07. What is the difference between the Aid flow (current US$) in Liberia in 2006 and the Aid flow (current US$) in Nepal in 2007?
Your answer should be very brief. -3.20e+07. What is the average Aid flow (current US$) of Bosnia and Herzegovina per year?
Provide a short and direct response. 2.05e+07. What is the average Aid flow (current US$) in Burkina Faso per year?
Provide a succinct answer. 2.84e+05. What is the average Aid flow (current US$) in Liberia per year?
Your answer should be very brief. 8.47e+06. What is the average Aid flow (current US$) of Nepal per year?
Offer a terse response. 2.30e+07. In the year 2000, what is the difference between the Aid flow (current US$) of Bosnia and Herzegovina and Aid flow (current US$) of Burkina Faso?
Your answer should be very brief. 3.03e+07. In the year 2000, what is the difference between the Aid flow (current US$) in Bosnia and Herzegovina and Aid flow (current US$) in Liberia?
Keep it short and to the point. 3.05e+07. In the year 2000, what is the difference between the Aid flow (current US$) in Bosnia and Herzegovina and Aid flow (current US$) in Nepal?
Provide a succinct answer. 2.19e+07. In the year 2000, what is the difference between the Aid flow (current US$) in Burkina Faso and Aid flow (current US$) in Nepal?
Make the answer very short. -8.47e+06. In the year 2000, what is the difference between the Aid flow (current US$) in Liberia and Aid flow (current US$) in Nepal?
Provide a succinct answer. -8.62e+06. In the year 2001, what is the difference between the Aid flow (current US$) of Bosnia and Herzegovina and Aid flow (current US$) of Burkina Faso?
Give a very brief answer. 1.66e+07. In the year 2001, what is the difference between the Aid flow (current US$) of Bosnia and Herzegovina and Aid flow (current US$) of Liberia?
Keep it short and to the point. 1.62e+07. In the year 2001, what is the difference between the Aid flow (current US$) of Bosnia and Herzegovina and Aid flow (current US$) of Nepal?
Ensure brevity in your answer.  5.38e+06. In the year 2001, what is the difference between the Aid flow (current US$) in Burkina Faso and Aid flow (current US$) in Liberia?
Give a very brief answer. -3.80e+05. In the year 2001, what is the difference between the Aid flow (current US$) in Burkina Faso and Aid flow (current US$) in Nepal?
Your response must be concise. -1.12e+07. In the year 2001, what is the difference between the Aid flow (current US$) in Liberia and Aid flow (current US$) in Nepal?
Your answer should be very brief. -1.08e+07. In the year 2002, what is the difference between the Aid flow (current US$) in Bosnia and Herzegovina and Aid flow (current US$) in Burkina Faso?
Provide a short and direct response. 2.35e+07. In the year 2002, what is the difference between the Aid flow (current US$) of Bosnia and Herzegovina and Aid flow (current US$) of Liberia?
Offer a very short reply. 2.19e+07. In the year 2002, what is the difference between the Aid flow (current US$) of Bosnia and Herzegovina and Aid flow (current US$) of Nepal?
Keep it short and to the point. 1.07e+07. In the year 2002, what is the difference between the Aid flow (current US$) of Burkina Faso and Aid flow (current US$) of Liberia?
Provide a succinct answer. -1.57e+06. In the year 2002, what is the difference between the Aid flow (current US$) of Burkina Faso and Aid flow (current US$) of Nepal?
Keep it short and to the point. -1.27e+07. In the year 2002, what is the difference between the Aid flow (current US$) in Liberia and Aid flow (current US$) in Nepal?
Offer a very short reply. -1.12e+07. In the year 2003, what is the difference between the Aid flow (current US$) of Bosnia and Herzegovina and Aid flow (current US$) of Burkina Faso?
Ensure brevity in your answer.  2.14e+07. In the year 2003, what is the difference between the Aid flow (current US$) in Bosnia and Herzegovina and Aid flow (current US$) in Liberia?
Ensure brevity in your answer.  1.26e+07. In the year 2003, what is the difference between the Aid flow (current US$) in Bosnia and Herzegovina and Aid flow (current US$) in Nepal?
Your answer should be very brief. 1.40e+06. In the year 2003, what is the difference between the Aid flow (current US$) in Burkina Faso and Aid flow (current US$) in Liberia?
Offer a terse response. -8.80e+06. In the year 2003, what is the difference between the Aid flow (current US$) of Burkina Faso and Aid flow (current US$) of Nepal?
Keep it short and to the point. -2.00e+07. In the year 2003, what is the difference between the Aid flow (current US$) in Liberia and Aid flow (current US$) in Nepal?
Your answer should be compact. -1.12e+07. In the year 2004, what is the difference between the Aid flow (current US$) in Bosnia and Herzegovina and Aid flow (current US$) in Burkina Faso?
Ensure brevity in your answer.  1.69e+07. In the year 2004, what is the difference between the Aid flow (current US$) of Bosnia and Herzegovina and Aid flow (current US$) of Liberia?
Your answer should be compact. 5.37e+06. In the year 2004, what is the difference between the Aid flow (current US$) in Bosnia and Herzegovina and Aid flow (current US$) in Nepal?
Provide a short and direct response. -6.01e+06. In the year 2004, what is the difference between the Aid flow (current US$) of Burkina Faso and Aid flow (current US$) of Liberia?
Provide a short and direct response. -1.15e+07. In the year 2004, what is the difference between the Aid flow (current US$) of Burkina Faso and Aid flow (current US$) of Nepal?
Give a very brief answer. -2.29e+07. In the year 2004, what is the difference between the Aid flow (current US$) of Liberia and Aid flow (current US$) of Nepal?
Your answer should be compact. -1.14e+07. In the year 2005, what is the difference between the Aid flow (current US$) in Bosnia and Herzegovina and Aid flow (current US$) in Burkina Faso?
Offer a very short reply. 1.75e+07. In the year 2005, what is the difference between the Aid flow (current US$) in Bosnia and Herzegovina and Aid flow (current US$) in Liberia?
Offer a terse response. 1.06e+07. In the year 2005, what is the difference between the Aid flow (current US$) in Bosnia and Herzegovina and Aid flow (current US$) in Nepal?
Offer a terse response. -7.43e+06. In the year 2005, what is the difference between the Aid flow (current US$) of Burkina Faso and Aid flow (current US$) of Liberia?
Ensure brevity in your answer.  -6.92e+06. In the year 2005, what is the difference between the Aid flow (current US$) of Burkina Faso and Aid flow (current US$) of Nepal?
Your answer should be compact. -2.49e+07. In the year 2005, what is the difference between the Aid flow (current US$) of Liberia and Aid flow (current US$) of Nepal?
Offer a terse response. -1.80e+07. In the year 2006, what is the difference between the Aid flow (current US$) of Bosnia and Herzegovina and Aid flow (current US$) of Burkina Faso?
Give a very brief answer. 1.86e+07. In the year 2006, what is the difference between the Aid flow (current US$) in Bosnia and Herzegovina and Aid flow (current US$) in Liberia?
Keep it short and to the point. 1.01e+07. In the year 2006, what is the difference between the Aid flow (current US$) in Bosnia and Herzegovina and Aid flow (current US$) in Nepal?
Give a very brief answer. -2.20e+07. In the year 2006, what is the difference between the Aid flow (current US$) in Burkina Faso and Aid flow (current US$) in Liberia?
Offer a very short reply. -8.57e+06. In the year 2006, what is the difference between the Aid flow (current US$) in Burkina Faso and Aid flow (current US$) in Nepal?
Offer a terse response. -4.06e+07. In the year 2006, what is the difference between the Aid flow (current US$) of Liberia and Aid flow (current US$) of Nepal?
Your response must be concise. -3.20e+07. In the year 2007, what is the difference between the Aid flow (current US$) in Bosnia and Herzegovina and Aid flow (current US$) in Burkina Faso?
Your answer should be very brief. 1.71e+07. In the year 2007, what is the difference between the Aid flow (current US$) in Bosnia and Herzegovina and Aid flow (current US$) in Liberia?
Offer a very short reply. -1.08e+07. In the year 2007, what is the difference between the Aid flow (current US$) in Bosnia and Herzegovina and Aid flow (current US$) in Nepal?
Provide a succinct answer. -2.35e+07. In the year 2007, what is the difference between the Aid flow (current US$) in Burkina Faso and Aid flow (current US$) in Liberia?
Keep it short and to the point. -2.79e+07. In the year 2007, what is the difference between the Aid flow (current US$) in Burkina Faso and Aid flow (current US$) in Nepal?
Ensure brevity in your answer.  -4.06e+07. In the year 2007, what is the difference between the Aid flow (current US$) in Liberia and Aid flow (current US$) in Nepal?
Your answer should be very brief. -1.27e+07. What is the ratio of the Aid flow (current US$) in Bosnia and Herzegovina in 2000 to that in 2001?
Your answer should be compact. 1.82. What is the ratio of the Aid flow (current US$) in Burkina Faso in 2000 to that in 2001?
Keep it short and to the point. 1.63. What is the ratio of the Aid flow (current US$) of Liberia in 2000 to that in 2001?
Offer a very short reply. 0.45. What is the ratio of the Aid flow (current US$) in Nepal in 2000 to that in 2001?
Provide a short and direct response. 0.78. What is the ratio of the Aid flow (current US$) of Bosnia and Herzegovina in 2000 to that in 2002?
Your answer should be very brief. 1.29. What is the ratio of the Aid flow (current US$) in Burkina Faso in 2000 to that in 2002?
Make the answer very short. 1.19. What is the ratio of the Aid flow (current US$) in Liberia in 2000 to that in 2002?
Ensure brevity in your answer.  0.15. What is the ratio of the Aid flow (current US$) in Nepal in 2000 to that in 2002?
Make the answer very short. 0.68. What is the ratio of the Aid flow (current US$) in Bosnia and Herzegovina in 2000 to that in 2003?
Offer a very short reply. 1.42. What is the ratio of the Aid flow (current US$) in Burkina Faso in 2000 to that in 2003?
Your response must be concise. 2.44. What is the ratio of the Aid flow (current US$) of Liberia in 2000 to that in 2003?
Give a very brief answer. 0.03. What is the ratio of the Aid flow (current US$) of Nepal in 2000 to that in 2003?
Your response must be concise. 0.44. What is the ratio of the Aid flow (current US$) in Bosnia and Herzegovina in 2000 to that in 2004?
Make the answer very short. 1.81. What is the ratio of the Aid flow (current US$) of Burkina Faso in 2000 to that in 2004?
Offer a very short reply. 2.93. What is the ratio of the Aid flow (current US$) of Liberia in 2000 to that in 2004?
Give a very brief answer. 0.02. What is the ratio of the Aid flow (current US$) in Nepal in 2000 to that in 2004?
Give a very brief answer. 0.39. What is the ratio of the Aid flow (current US$) of Bosnia and Herzegovina in 2000 to that in 2005?
Provide a succinct answer. 1.74. What is the ratio of the Aid flow (current US$) in Burkina Faso in 2000 to that in 2005?
Your response must be concise. 2. What is the ratio of the Aid flow (current US$) in Liberia in 2000 to that in 2005?
Provide a short and direct response. 0.04. What is the ratio of the Aid flow (current US$) of Nepal in 2000 to that in 2005?
Your answer should be very brief. 0.35. What is the ratio of the Aid flow (current US$) in Bosnia and Herzegovina in 2000 to that in 2006?
Your answer should be very brief. 1.62. What is the ratio of the Aid flow (current US$) of Burkina Faso in 2000 to that in 2006?
Keep it short and to the point. 1.19. What is the ratio of the Aid flow (current US$) in Liberia in 2000 to that in 2006?
Provide a short and direct response. 0.03. What is the ratio of the Aid flow (current US$) in Nepal in 2000 to that in 2006?
Provide a short and direct response. 0.22. What is the ratio of the Aid flow (current US$) of Bosnia and Herzegovina in 2000 to that in 2007?
Offer a very short reply. 1.77. What is the ratio of the Aid flow (current US$) of Burkina Faso in 2000 to that in 2007?
Your answer should be very brief. 1.63. What is the ratio of the Aid flow (current US$) in Liberia in 2000 to that in 2007?
Your response must be concise. 0.01. What is the ratio of the Aid flow (current US$) of Nepal in 2000 to that in 2007?
Your response must be concise. 0.22. What is the ratio of the Aid flow (current US$) of Bosnia and Herzegovina in 2001 to that in 2002?
Provide a short and direct response. 0.71. What is the ratio of the Aid flow (current US$) of Burkina Faso in 2001 to that in 2002?
Give a very brief answer. 0.73. What is the ratio of the Aid flow (current US$) of Liberia in 2001 to that in 2002?
Provide a succinct answer. 0.34. What is the ratio of the Aid flow (current US$) in Nepal in 2001 to that in 2002?
Your answer should be compact. 0.88. What is the ratio of the Aid flow (current US$) of Bosnia and Herzegovina in 2001 to that in 2003?
Your response must be concise. 0.78. What is the ratio of the Aid flow (current US$) of Liberia in 2001 to that in 2003?
Your response must be concise. 0.07. What is the ratio of the Aid flow (current US$) in Nepal in 2001 to that in 2003?
Offer a very short reply. 0.57. What is the ratio of the Aid flow (current US$) in Bosnia and Herzegovina in 2001 to that in 2004?
Provide a short and direct response. 0.99. What is the ratio of the Aid flow (current US$) of Burkina Faso in 2001 to that in 2004?
Keep it short and to the point. 1.8. What is the ratio of the Aid flow (current US$) of Liberia in 2001 to that in 2004?
Provide a succinct answer. 0.06. What is the ratio of the Aid flow (current US$) of Nepal in 2001 to that in 2004?
Offer a very short reply. 0.5. What is the ratio of the Aid flow (current US$) of Bosnia and Herzegovina in 2001 to that in 2005?
Give a very brief answer. 0.95. What is the ratio of the Aid flow (current US$) of Burkina Faso in 2001 to that in 2005?
Your response must be concise. 1.23. What is the ratio of the Aid flow (current US$) of Liberia in 2001 to that in 2005?
Your answer should be compact. 0.09. What is the ratio of the Aid flow (current US$) in Nepal in 2001 to that in 2005?
Give a very brief answer. 0.46. What is the ratio of the Aid flow (current US$) in Bosnia and Herzegovina in 2001 to that in 2006?
Offer a very short reply. 0.89. What is the ratio of the Aid flow (current US$) of Burkina Faso in 2001 to that in 2006?
Make the answer very short. 0.73. What is the ratio of the Aid flow (current US$) in Liberia in 2001 to that in 2006?
Provide a succinct answer. 0.07. What is the ratio of the Aid flow (current US$) of Nepal in 2001 to that in 2006?
Make the answer very short. 0.28. What is the ratio of the Aid flow (current US$) in Bosnia and Herzegovina in 2001 to that in 2007?
Your response must be concise. 0.97. What is the ratio of the Aid flow (current US$) in Burkina Faso in 2001 to that in 2007?
Keep it short and to the point. 1. What is the ratio of the Aid flow (current US$) of Liberia in 2001 to that in 2007?
Ensure brevity in your answer.  0.02. What is the ratio of the Aid flow (current US$) in Nepal in 2001 to that in 2007?
Ensure brevity in your answer.  0.28. What is the ratio of the Aid flow (current US$) in Bosnia and Herzegovina in 2002 to that in 2003?
Make the answer very short. 1.1. What is the ratio of the Aid flow (current US$) of Burkina Faso in 2002 to that in 2003?
Offer a very short reply. 2.06. What is the ratio of the Aid flow (current US$) in Liberia in 2002 to that in 2003?
Provide a short and direct response. 0.22. What is the ratio of the Aid flow (current US$) in Nepal in 2002 to that in 2003?
Provide a succinct answer. 0.65. What is the ratio of the Aid flow (current US$) of Bosnia and Herzegovina in 2002 to that in 2004?
Provide a short and direct response. 1.4. What is the ratio of the Aid flow (current US$) of Burkina Faso in 2002 to that in 2004?
Offer a terse response. 2.47. What is the ratio of the Aid flow (current US$) in Nepal in 2002 to that in 2004?
Provide a succinct answer. 0.57. What is the ratio of the Aid flow (current US$) in Bosnia and Herzegovina in 2002 to that in 2005?
Provide a succinct answer. 1.35. What is the ratio of the Aid flow (current US$) in Burkina Faso in 2002 to that in 2005?
Your answer should be very brief. 1.68. What is the ratio of the Aid flow (current US$) in Liberia in 2002 to that in 2005?
Your answer should be compact. 0.27. What is the ratio of the Aid flow (current US$) in Nepal in 2002 to that in 2005?
Give a very brief answer. 0.52. What is the ratio of the Aid flow (current US$) of Bosnia and Herzegovina in 2002 to that in 2006?
Provide a short and direct response. 1.25. What is the ratio of the Aid flow (current US$) in Liberia in 2002 to that in 2006?
Keep it short and to the point. 0.22. What is the ratio of the Aid flow (current US$) in Nepal in 2002 to that in 2006?
Your answer should be compact. 0.32. What is the ratio of the Aid flow (current US$) in Bosnia and Herzegovina in 2002 to that in 2007?
Provide a short and direct response. 1.37. What is the ratio of the Aid flow (current US$) of Burkina Faso in 2002 to that in 2007?
Your response must be concise. 1.37. What is the ratio of the Aid flow (current US$) in Liberia in 2002 to that in 2007?
Offer a very short reply. 0.07. What is the ratio of the Aid flow (current US$) in Nepal in 2002 to that in 2007?
Your answer should be compact. 0.32. What is the ratio of the Aid flow (current US$) of Bosnia and Herzegovina in 2003 to that in 2004?
Your answer should be compact. 1.27. What is the ratio of the Aid flow (current US$) in Burkina Faso in 2003 to that in 2004?
Make the answer very short. 1.2. What is the ratio of the Aid flow (current US$) of Liberia in 2003 to that in 2004?
Provide a succinct answer. 0.77. What is the ratio of the Aid flow (current US$) of Nepal in 2003 to that in 2004?
Offer a very short reply. 0.88. What is the ratio of the Aid flow (current US$) in Bosnia and Herzegovina in 2003 to that in 2005?
Keep it short and to the point. 1.22. What is the ratio of the Aid flow (current US$) of Burkina Faso in 2003 to that in 2005?
Offer a terse response. 0.82. What is the ratio of the Aid flow (current US$) of Liberia in 2003 to that in 2005?
Offer a terse response. 1.26. What is the ratio of the Aid flow (current US$) in Nepal in 2003 to that in 2005?
Keep it short and to the point. 0.8. What is the ratio of the Aid flow (current US$) of Bosnia and Herzegovina in 2003 to that in 2006?
Ensure brevity in your answer.  1.14. What is the ratio of the Aid flow (current US$) of Burkina Faso in 2003 to that in 2006?
Make the answer very short. 0.49. What is the ratio of the Aid flow (current US$) of Liberia in 2003 to that in 2006?
Your response must be concise. 1. What is the ratio of the Aid flow (current US$) of Nepal in 2003 to that in 2006?
Offer a terse response. 0.49. What is the ratio of the Aid flow (current US$) in Bosnia and Herzegovina in 2003 to that in 2007?
Your response must be concise. 1.24. What is the ratio of the Aid flow (current US$) of Liberia in 2003 to that in 2007?
Offer a very short reply. 0.32. What is the ratio of the Aid flow (current US$) of Nepal in 2003 to that in 2007?
Your answer should be compact. 0.49. What is the ratio of the Aid flow (current US$) in Bosnia and Herzegovina in 2004 to that in 2005?
Keep it short and to the point. 0.96. What is the ratio of the Aid flow (current US$) of Burkina Faso in 2004 to that in 2005?
Your answer should be very brief. 0.68. What is the ratio of the Aid flow (current US$) of Liberia in 2004 to that in 2005?
Offer a terse response. 1.63. What is the ratio of the Aid flow (current US$) of Nepal in 2004 to that in 2005?
Provide a short and direct response. 0.92. What is the ratio of the Aid flow (current US$) of Bosnia and Herzegovina in 2004 to that in 2006?
Your answer should be compact. 0.89. What is the ratio of the Aid flow (current US$) of Burkina Faso in 2004 to that in 2006?
Ensure brevity in your answer.  0.41. What is the ratio of the Aid flow (current US$) in Liberia in 2004 to that in 2006?
Your answer should be very brief. 1.3. What is the ratio of the Aid flow (current US$) of Nepal in 2004 to that in 2006?
Your response must be concise. 0.56. What is the ratio of the Aid flow (current US$) of Bosnia and Herzegovina in 2004 to that in 2007?
Keep it short and to the point. 0.98. What is the ratio of the Aid flow (current US$) of Burkina Faso in 2004 to that in 2007?
Make the answer very short. 0.56. What is the ratio of the Aid flow (current US$) of Liberia in 2004 to that in 2007?
Provide a short and direct response. 0.41. What is the ratio of the Aid flow (current US$) of Nepal in 2004 to that in 2007?
Give a very brief answer. 0.56. What is the ratio of the Aid flow (current US$) of Bosnia and Herzegovina in 2005 to that in 2006?
Offer a very short reply. 0.93. What is the ratio of the Aid flow (current US$) in Burkina Faso in 2005 to that in 2006?
Your answer should be compact. 0.59. What is the ratio of the Aid flow (current US$) of Liberia in 2005 to that in 2006?
Your response must be concise. 0.8. What is the ratio of the Aid flow (current US$) of Nepal in 2005 to that in 2006?
Provide a succinct answer. 0.61. What is the ratio of the Aid flow (current US$) in Bosnia and Herzegovina in 2005 to that in 2007?
Give a very brief answer. 1.02. What is the ratio of the Aid flow (current US$) of Burkina Faso in 2005 to that in 2007?
Make the answer very short. 0.81. What is the ratio of the Aid flow (current US$) of Liberia in 2005 to that in 2007?
Ensure brevity in your answer.  0.25. What is the ratio of the Aid flow (current US$) in Nepal in 2005 to that in 2007?
Ensure brevity in your answer.  0.61. What is the ratio of the Aid flow (current US$) of Bosnia and Herzegovina in 2006 to that in 2007?
Keep it short and to the point. 1.09. What is the ratio of the Aid flow (current US$) in Burkina Faso in 2006 to that in 2007?
Keep it short and to the point. 1.37. What is the ratio of the Aid flow (current US$) of Liberia in 2006 to that in 2007?
Offer a terse response. 0.32. What is the ratio of the Aid flow (current US$) of Nepal in 2006 to that in 2007?
Offer a terse response. 1. What is the difference between the highest and the second highest Aid flow (current US$) in Bosnia and Herzegovina?
Keep it short and to the point. 6.95e+06. What is the difference between the highest and the second highest Aid flow (current US$) of Burkina Faso?
Your response must be concise. 7.00e+04. What is the difference between the highest and the second highest Aid flow (current US$) in Liberia?
Provide a succinct answer. 1.65e+07. What is the difference between the highest and the second highest Aid flow (current US$) of Nepal?
Keep it short and to the point. 6.00e+04. What is the difference between the highest and the lowest Aid flow (current US$) in Bosnia and Herzegovina?
Offer a very short reply. 1.39e+07. What is the difference between the highest and the lowest Aid flow (current US$) of Burkina Faso?
Keep it short and to the point. 2.90e+05. What is the difference between the highest and the lowest Aid flow (current US$) of Liberia?
Provide a short and direct response. 2.79e+07. What is the difference between the highest and the lowest Aid flow (current US$) of Nepal?
Give a very brief answer. 3.20e+07. 